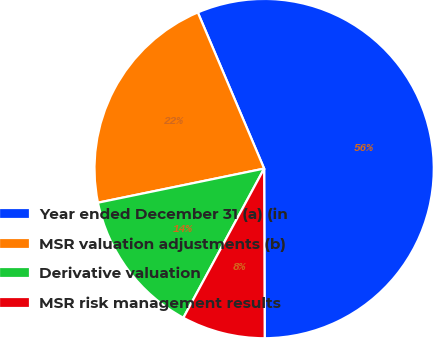Convert chart. <chart><loc_0><loc_0><loc_500><loc_500><pie_chart><fcel>Year ended December 31 (a) (in<fcel>MSR valuation adjustments (b)<fcel>Derivative valuation<fcel>MSR risk management results<nl><fcel>56.34%<fcel>21.83%<fcel>13.88%<fcel>7.95%<nl></chart> 